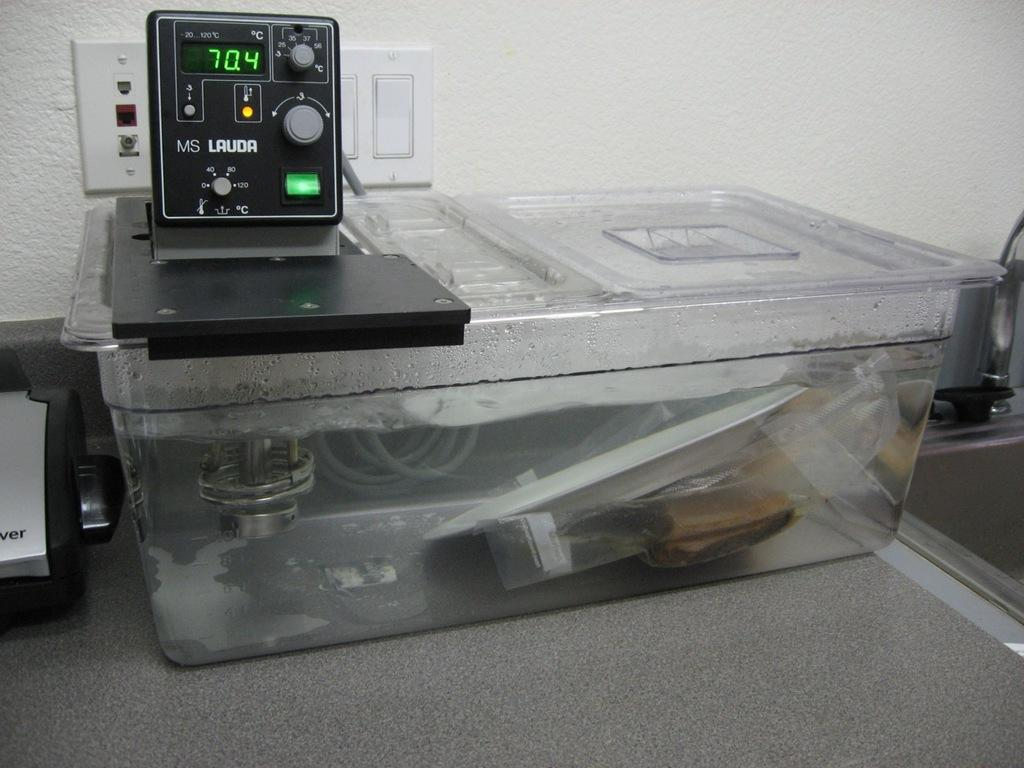<image>
Present a compact description of the photo's key features. A machine from MS Lauda is on a big plastic container 